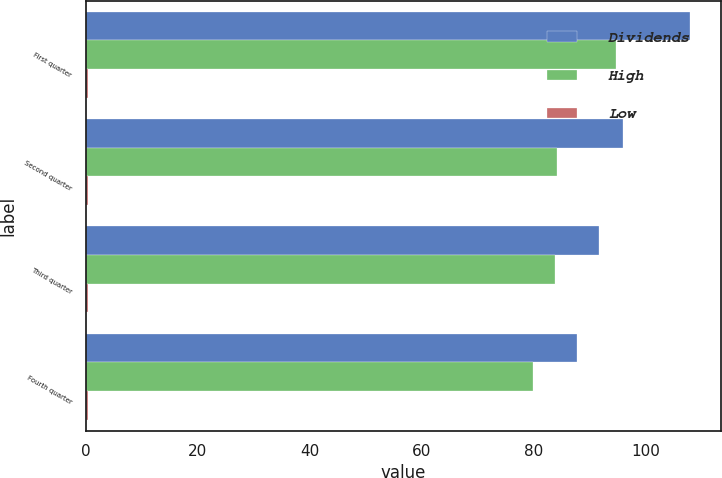Convert chart to OTSL. <chart><loc_0><loc_0><loc_500><loc_500><stacked_bar_chart><ecel><fcel>First quarter<fcel>Second quarter<fcel>Third quarter<fcel>Fourth quarter<nl><fcel>Dividends<fcel>108<fcel>96<fcel>91.63<fcel>87.83<nl><fcel>High<fcel>94.63<fcel>84.23<fcel>83.84<fcel>79.84<nl><fcel>Low<fcel>0.41<fcel>0.41<fcel>0.41<fcel>0.41<nl></chart> 